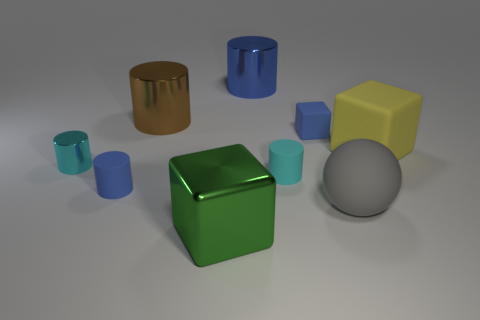There is another large object that is the same shape as the yellow object; what material is it?
Ensure brevity in your answer.  Metal. What number of small things are either gray matte things or brown metal cubes?
Give a very brief answer. 0. Are there fewer metallic cubes that are to the left of the shiny block than metal objects in front of the gray thing?
Your response must be concise. Yes. How many things are either blue matte things or green matte objects?
Provide a succinct answer. 2. There is a large brown metal object; what number of tiny blocks are behind it?
Provide a succinct answer. 0. Is the big rubber sphere the same color as the small metallic thing?
Give a very brief answer. No. There is a blue object that is made of the same material as the large green block; what shape is it?
Keep it short and to the point. Cylinder. Do the small blue object that is in front of the blue block and the tiny cyan rubber thing have the same shape?
Your answer should be very brief. Yes. What number of blue objects are big blocks or small blocks?
Your response must be concise. 1. Is the number of small metallic things that are on the right side of the gray ball the same as the number of big rubber objects behind the yellow rubber cube?
Your response must be concise. Yes. 